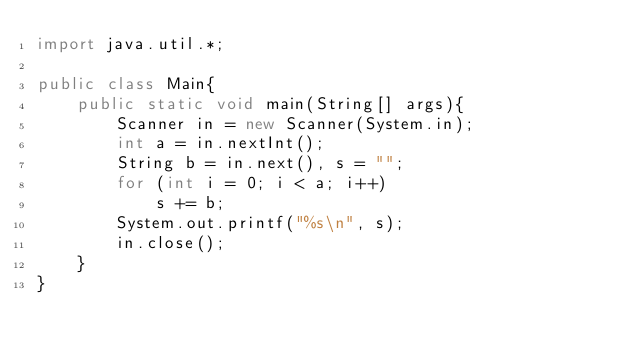<code> <loc_0><loc_0><loc_500><loc_500><_Java_>import java.util.*;
 
public class Main{
    public static void main(String[] args){
        Scanner in = new Scanner(System.in);
        int a = in.nextInt();
        String b = in.next(), s = "";
        for (int i = 0; i < a; i++)
            s += b;
        System.out.printf("%s\n", s);
        in.close();
    }
}
</code> 